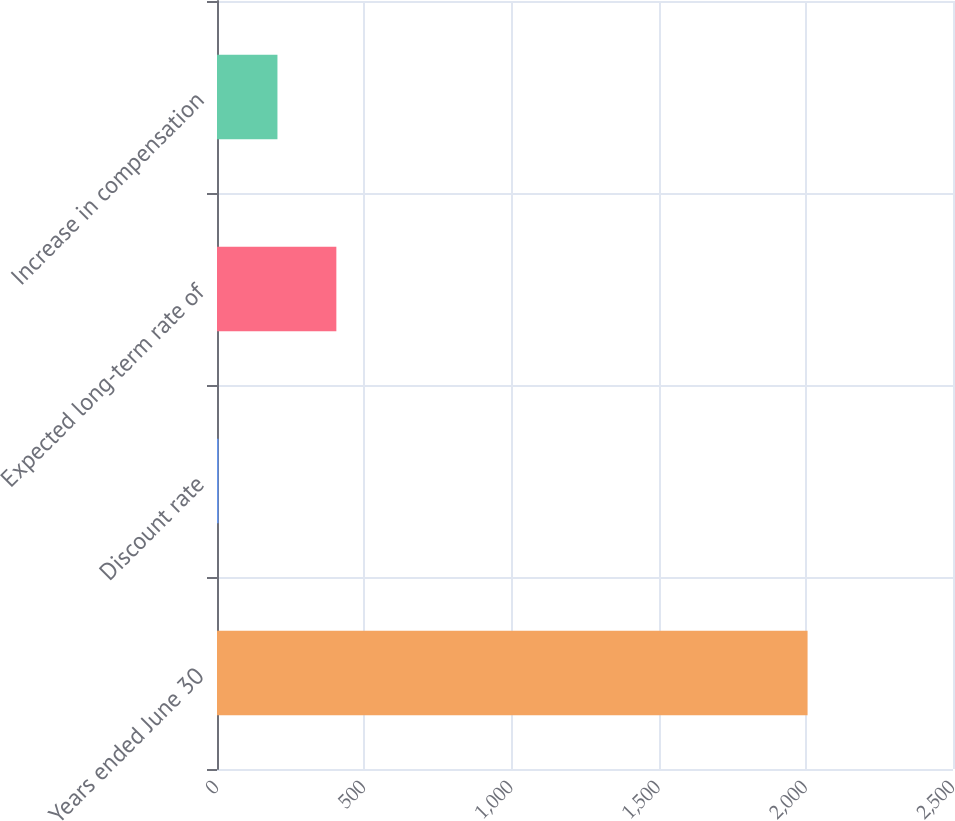Convert chart to OTSL. <chart><loc_0><loc_0><loc_500><loc_500><bar_chart><fcel>Years ended June 30<fcel>Discount rate<fcel>Expected long-term rate of<fcel>Increase in compensation<nl><fcel>2006<fcel>5.25<fcel>405.41<fcel>205.33<nl></chart> 